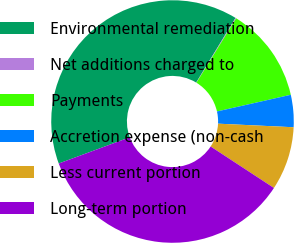Convert chart to OTSL. <chart><loc_0><loc_0><loc_500><loc_500><pie_chart><fcel>Environmental remediation<fcel>Net additions charged to<fcel>Payments<fcel>Accretion expense (non-cash<fcel>Less current portion<fcel>Long-term portion<nl><fcel>39.33%<fcel>0.1%<fcel>12.67%<fcel>4.29%<fcel>8.48%<fcel>35.14%<nl></chart> 